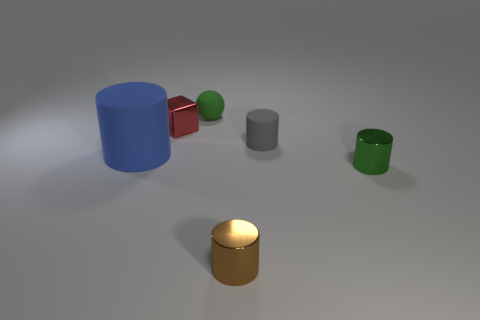What number of green rubber objects have the same shape as the blue object?
Your response must be concise. 0. What number of purple things are either small things or blocks?
Ensure brevity in your answer.  0. There is a metallic object behind the small green object in front of the small rubber cylinder; what size is it?
Provide a short and direct response. Small. There is a blue object that is the same shape as the gray rubber object; what is it made of?
Provide a succinct answer. Rubber. What number of blue rubber objects are the same size as the gray cylinder?
Your answer should be very brief. 0. Is the size of the red thing the same as the green cylinder?
Offer a terse response. Yes. There is a matte object that is both in front of the tiny green matte sphere and on the left side of the brown thing; how big is it?
Keep it short and to the point. Large. Is the number of small balls that are to the left of the sphere greater than the number of small red cubes in front of the blue matte thing?
Provide a short and direct response. No. There is a big object that is the same shape as the small green metal object; what is its color?
Give a very brief answer. Blue. There is a matte object left of the small red shiny thing; is its color the same as the matte sphere?
Your answer should be compact. No. 